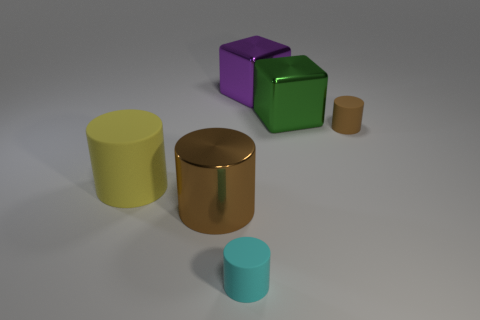Are there any reflective surfaces visible? Yes, all the objects have a certain level of reflectivity. The surfaces seem to have a matte finish, but you can see subtle reflections and highlights that suggest a metallic texture. The floor itself also reflects the objects very faintly, indicating a somewhat reflective surface. 